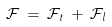<formula> <loc_0><loc_0><loc_500><loc_500>{ \mathcal { F } } \, = \, { \mathcal { F } } _ { t } \, + \, { \mathcal { F } } _ { l }</formula> 